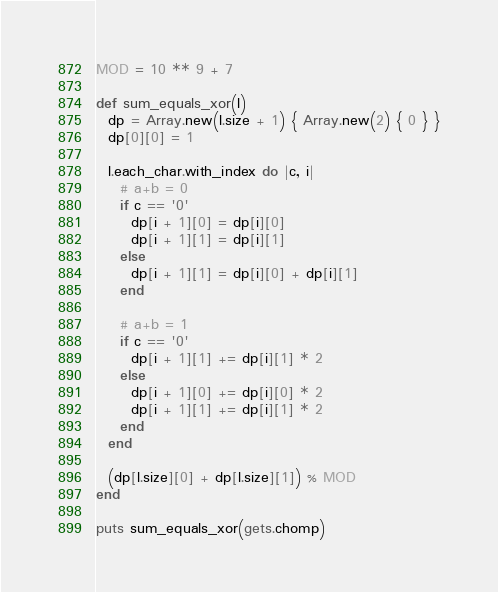<code> <loc_0><loc_0><loc_500><loc_500><_Ruby_>MOD = 10 ** 9 + 7

def sum_equals_xor(l)
  dp = Array.new(l.size + 1) { Array.new(2) { 0 } }
  dp[0][0] = 1

  l.each_char.with_index do |c, i|
    # a+b = 0
    if c == '0'
      dp[i + 1][0] = dp[i][0]
      dp[i + 1][1] = dp[i][1]
    else
      dp[i + 1][1] = dp[i][0] + dp[i][1]
    end

    # a+b = 1
    if c == '0'
      dp[i + 1][1] += dp[i][1] * 2
    else
      dp[i + 1][0] += dp[i][0] * 2
      dp[i + 1][1] += dp[i][1] * 2
    end
  end

  (dp[l.size][0] + dp[l.size][1]) % MOD
end

puts sum_equals_xor(gets.chomp)</code> 